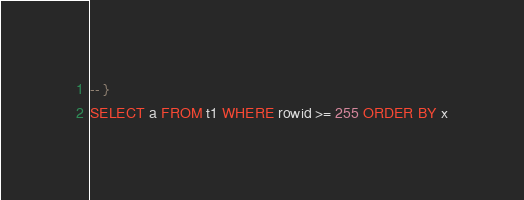Convert code to text. <code><loc_0><loc_0><loc_500><loc_500><_SQL_>-- }
SELECT a FROM t1 WHERE rowid >= 255 ORDER BY x</code> 